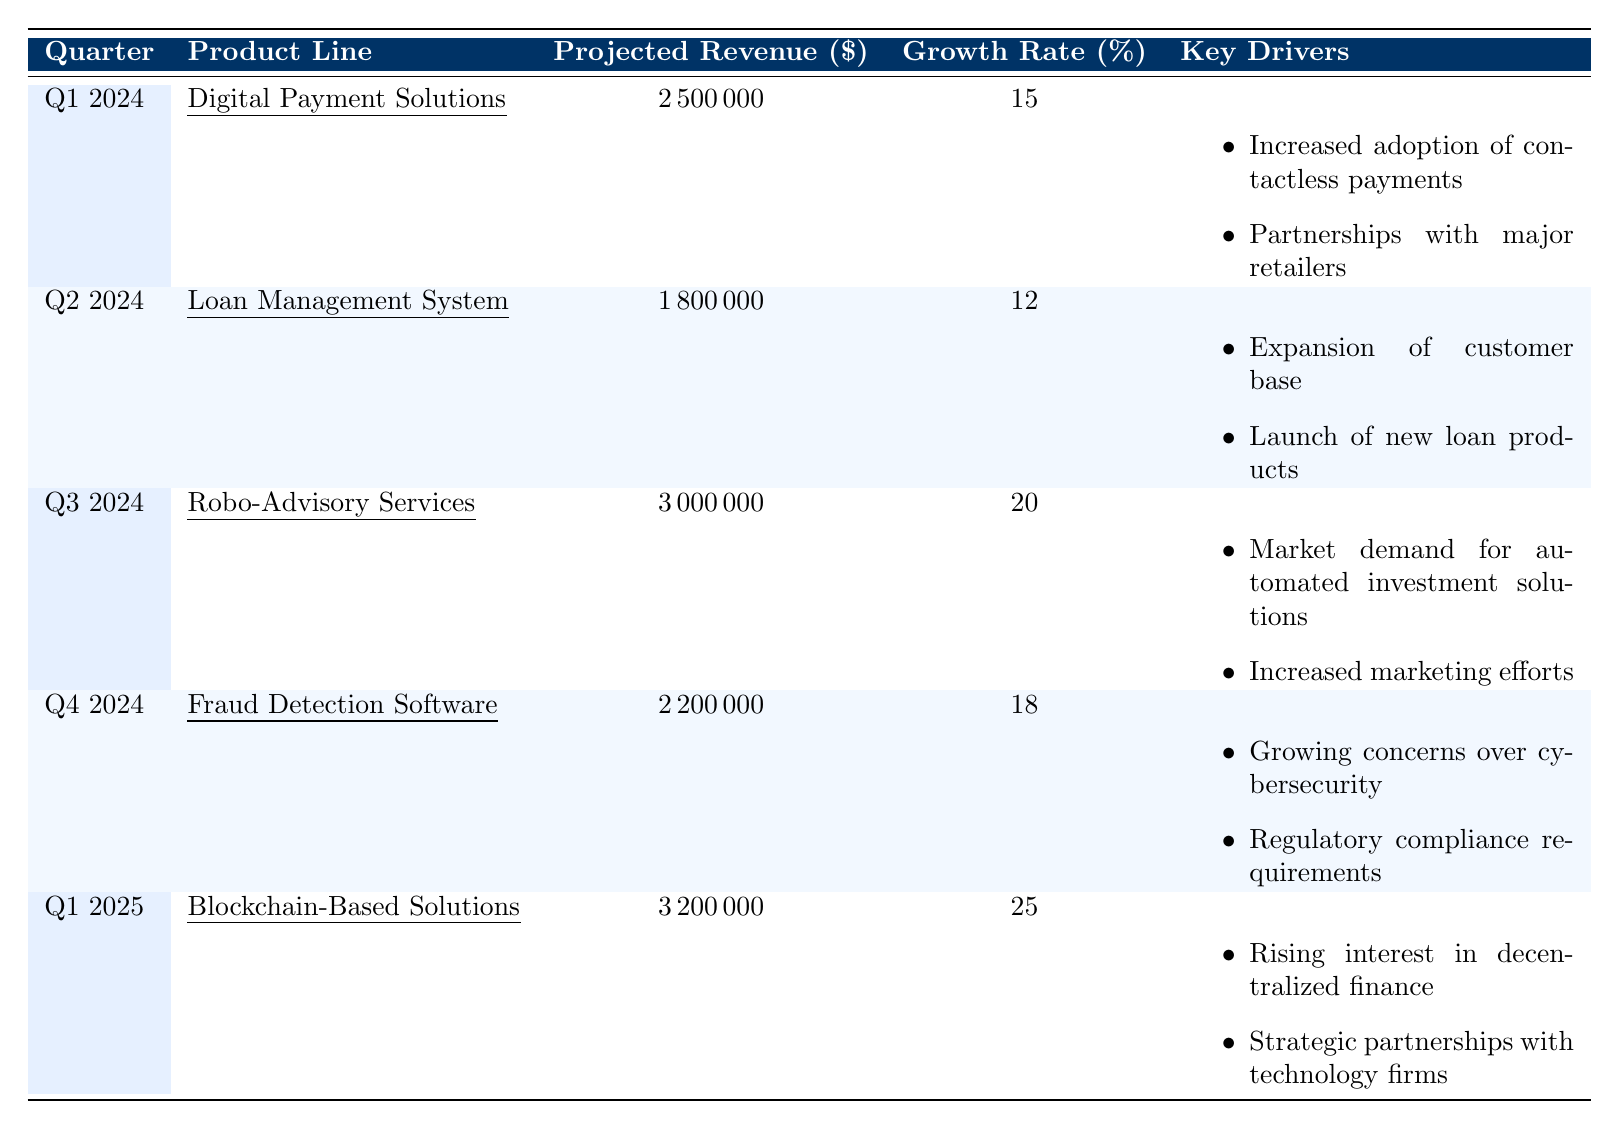What is the projected revenue for Q2 2024? The table specifies that the projected revenue for Q2 2024 under the "Loan Management System" product line is $1,800,000.
Answer: $1,800,000 Which product line has the highest projected revenue? The "Blockchain-Based Solutions" product line in Q1 2025 has the highest projected revenue of $3,200,000.
Answer: Blockchain-Based Solutions What is the average growth rate for all product lines in 2024? To find the average growth rate for all quarters in 2024, add the growth rates: (15 + 12 + 20 + 18) = 65. Then divide by the number of quarters, which is 4: 65/4 = 16.25.
Answer: 16.25% Is there a product line projected to generate over $3 million in Q4 2024? No, the highest projected revenue in Q4 2024 is for "Fraud Detection Software" at $2,200,000, which is below $3 million.
Answer: No What is the difference in projected revenue between Q1 2025 and Q1 2024? Subtract the projected revenue for Q1 2024 ($2,500,000) from the projected revenue for Q1 2025 ($3,200,000): $3,200,000 - $2,500,000 = $700,000.
Answer: $700,000 Which product line exhibits the highest growth rate and what is it? The product line "Blockchain-Based Solutions" for Q1 2025 shows the highest growth rate of 25%.
Answer: Blockchain-Based Solutions, 25% Are there any product lines that involve compliance or regulatory concerns? Yes, the "Fraud Detection Software" product line in Q4 2024 cites regulatory compliance requirements as one of its key drivers, confirming compliance concerns.
Answer: Yes What are the key drivers for the Robo-Advisory Services? The key drivers for "Robo-Advisory Services" in Q3 2024 are "market demand for automated investment solutions" and "increased marketing efforts."
Answer: Market demand for automated investment solutions; Increased marketing efforts What is the total projected revenue across all product lines for Q1 2024 and Q2 2024? Sum the projected revenue for Q1 2024 ($2,500,000) and Q2 2024 ($1,800,000): $2,500,000 + $1,800,000 = $4,300,000.
Answer: $4,300,000 Which quarter has the lowest projected revenue, and what is that revenue? Q2 2024 has the lowest projected revenue of $1,800,000 for the product line "Loan Management System."
Answer: Q2 2024, $1,800,000 